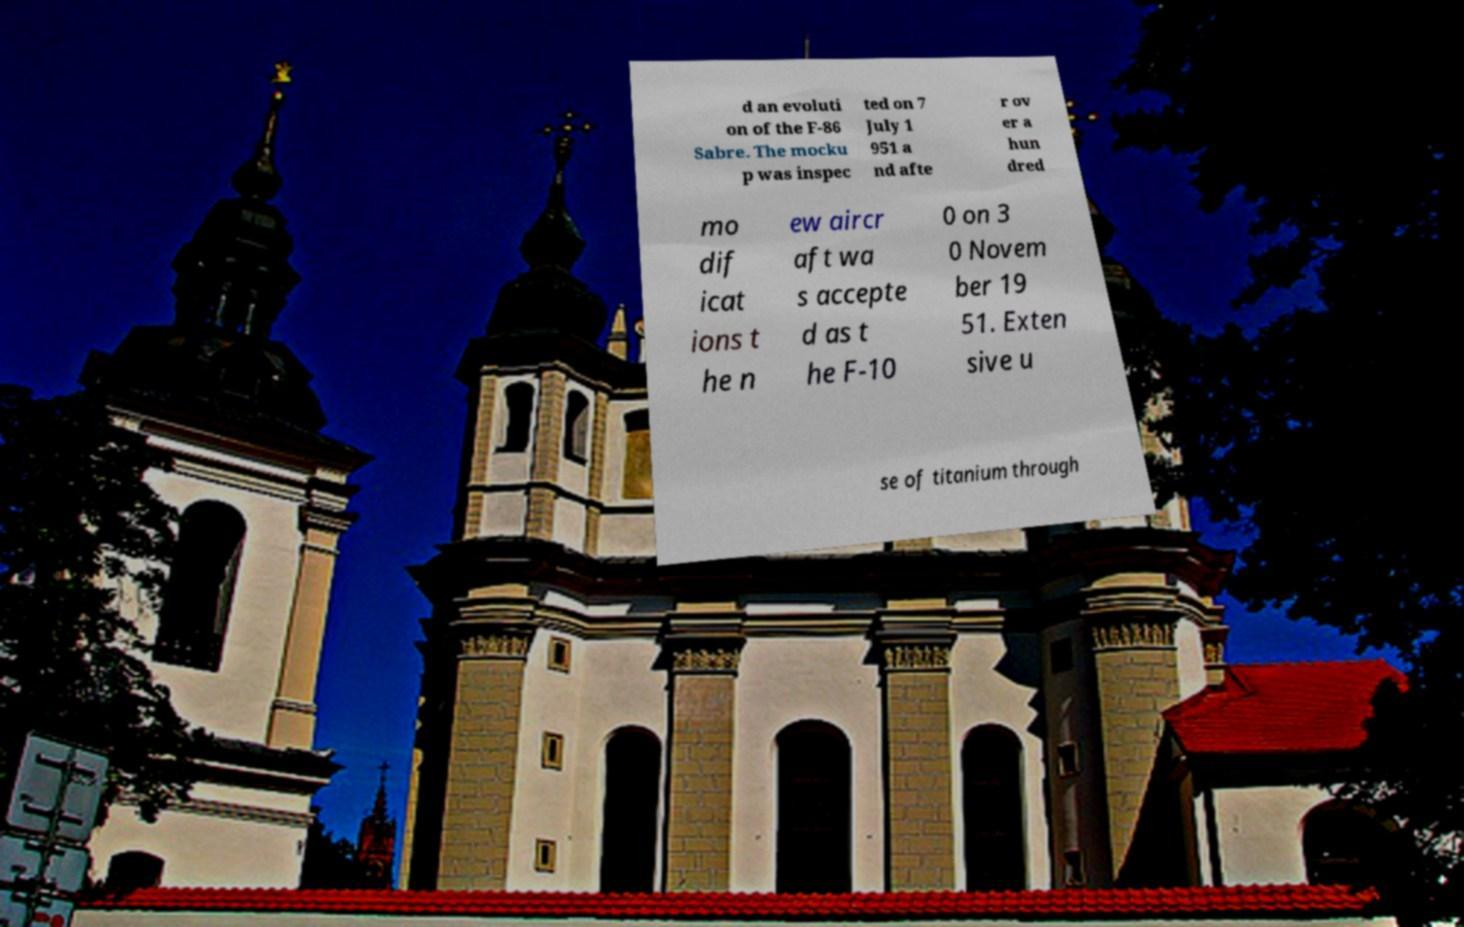I need the written content from this picture converted into text. Can you do that? d an evoluti on of the F-86 Sabre. The mocku p was inspec ted on 7 July 1 951 a nd afte r ov er a hun dred mo dif icat ions t he n ew aircr aft wa s accepte d as t he F-10 0 on 3 0 Novem ber 19 51. Exten sive u se of titanium through 